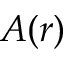<formula> <loc_0><loc_0><loc_500><loc_500>A ( r )</formula> 